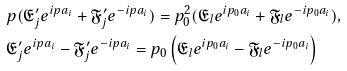<formula> <loc_0><loc_0><loc_500><loc_500>& p ( \mathfrak { E } _ { j } ^ { \prime } e ^ { i p a _ { i } } + \mathfrak { F } _ { j } ^ { \prime } e ^ { - i p a _ { i } } ) = p _ { 0 } ^ { 2 } ( \mathfrak { E } _ { l } e ^ { i p _ { 0 } a _ { i } } + \mathfrak { F } _ { l } e ^ { - i p _ { 0 } a _ { i } } ) , \\ & \mathfrak { E } _ { j } ^ { \prime } e ^ { i p a _ { i } } - \mathfrak { F } _ { j } ^ { \prime } e ^ { - i p a _ { i } } = p _ { 0 } \left ( \mathfrak { E } _ { l } e ^ { i p _ { 0 } a _ { i } } - \mathfrak { F } _ { l } e ^ { - i p _ { 0 } a _ { i } } \right )</formula> 